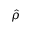<formula> <loc_0><loc_0><loc_500><loc_500>\hat { \rho }</formula> 